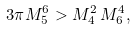Convert formula to latex. <formula><loc_0><loc_0><loc_500><loc_500>3 \pi M _ { 5 } ^ { 6 } > { M _ { 4 } ^ { 2 } \, M _ { 6 } ^ { 4 } } ,</formula> 